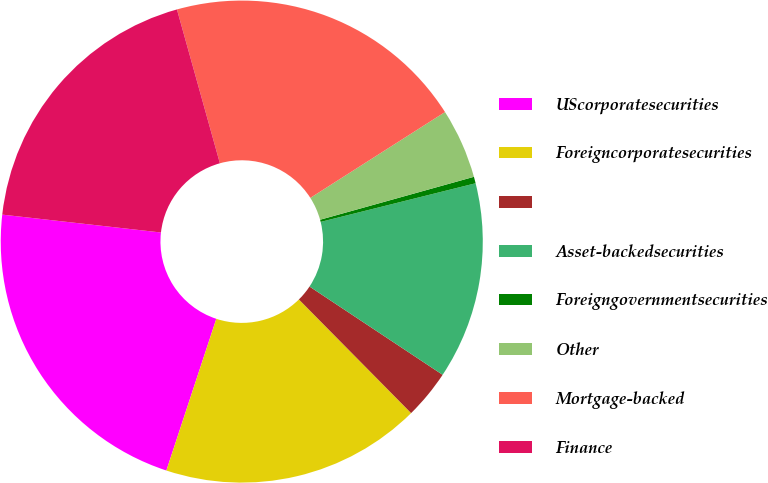Convert chart to OTSL. <chart><loc_0><loc_0><loc_500><loc_500><pie_chart><fcel>UScorporatesecurities<fcel>Foreigncorporatesecurities<fcel>Unnamed: 2<fcel>Asset-backedsecurities<fcel>Foreigngovernmentsecurities<fcel>Other<fcel>Mortgage-backed<fcel>Finance<nl><fcel>21.72%<fcel>17.46%<fcel>3.28%<fcel>13.21%<fcel>0.44%<fcel>4.7%<fcel>20.3%<fcel>18.88%<nl></chart> 